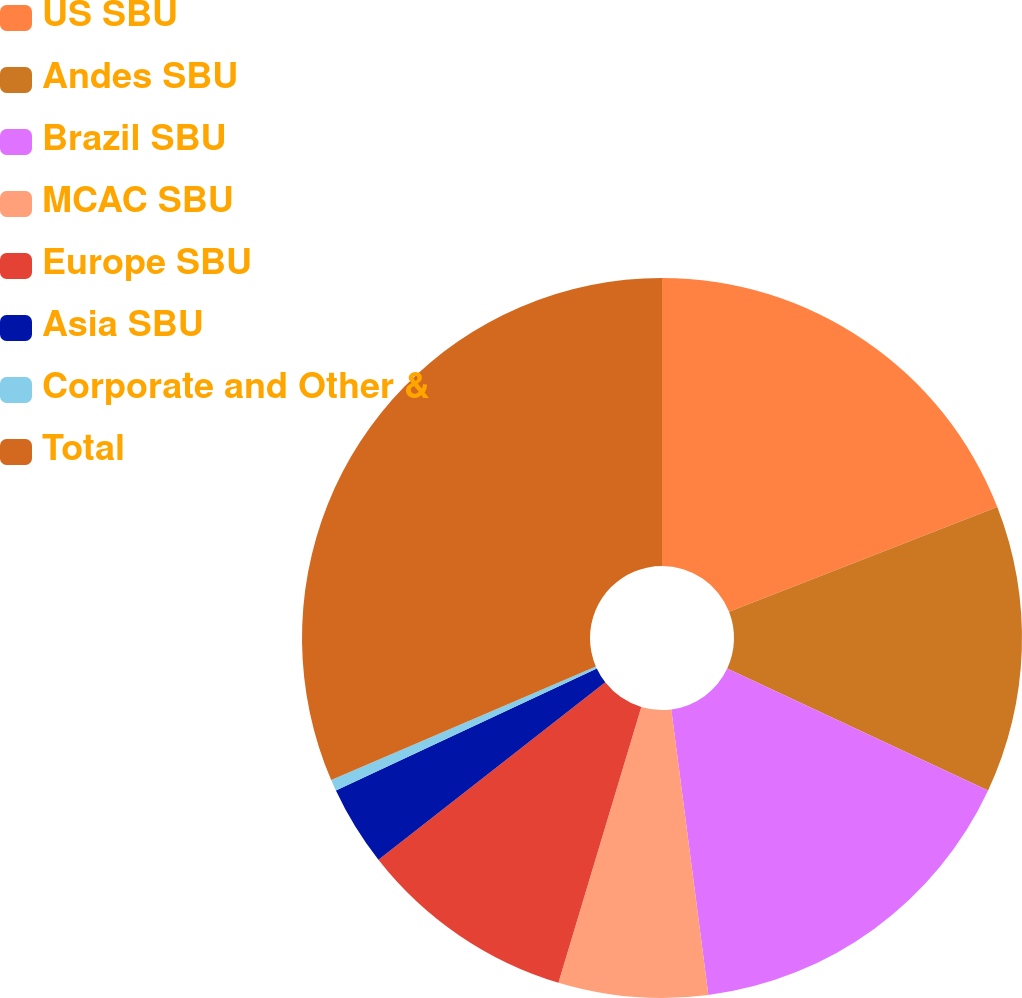Convert chart to OTSL. <chart><loc_0><loc_0><loc_500><loc_500><pie_chart><fcel>US SBU<fcel>Andes SBU<fcel>Brazil SBU<fcel>MCAC SBU<fcel>Europe SBU<fcel>Asia SBU<fcel>Corporate and Other &<fcel>Total<nl><fcel>19.07%<fcel>12.89%<fcel>15.98%<fcel>6.7%<fcel>9.79%<fcel>3.6%<fcel>0.51%<fcel>31.45%<nl></chart> 